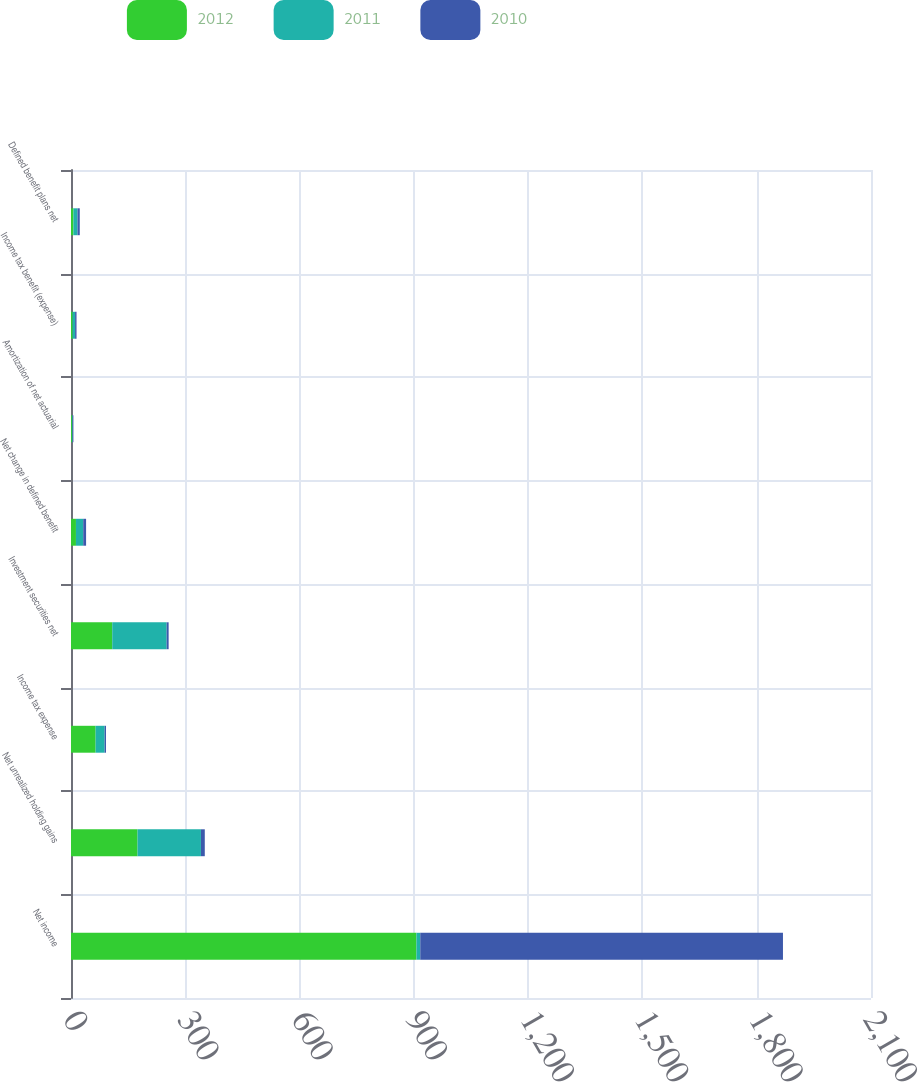Convert chart. <chart><loc_0><loc_0><loc_500><loc_500><stacked_bar_chart><ecel><fcel>Net income<fcel>Net unrealized holding gains<fcel>Income tax expense<fcel>Investment securities net<fcel>Net change in defined benefit<fcel>Amortization of net actuarial<fcel>Income tax benefit (expense)<fcel>Defined benefit plans net<nl><fcel>2012<fcel>906.7<fcel>174.7<fcel>64.6<fcel>108.3<fcel>13<fcel>2.5<fcel>4.2<fcel>6.3<nl><fcel>2011<fcel>10.1<fcel>166.4<fcel>23.7<fcel>142.7<fcel>19.1<fcel>1.7<fcel>6.5<fcel>10.9<nl><fcel>2010<fcel>952.1<fcel>10.1<fcel>3.6<fcel>5.3<fcel>7.5<fcel>2.1<fcel>3.8<fcel>5.8<nl></chart> 